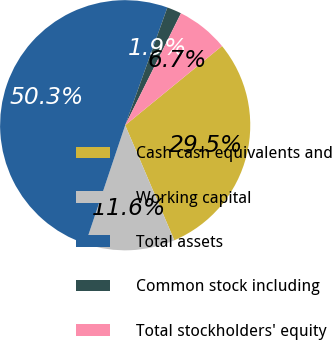Convert chart to OTSL. <chart><loc_0><loc_0><loc_500><loc_500><pie_chart><fcel>Cash cash equivalents and<fcel>Working capital<fcel>Total assets<fcel>Common stock including<fcel>Total stockholders' equity<nl><fcel>29.49%<fcel>11.57%<fcel>50.33%<fcel>1.88%<fcel>6.73%<nl></chart> 